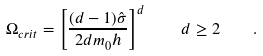Convert formula to latex. <formula><loc_0><loc_0><loc_500><loc_500>\Omega _ { c r i t } = \left [ \frac { ( d - 1 ) \hat { \sigma } } { 2 d m _ { 0 } h } \right ] ^ { d } \quad d \geq 2 \quad .</formula> 